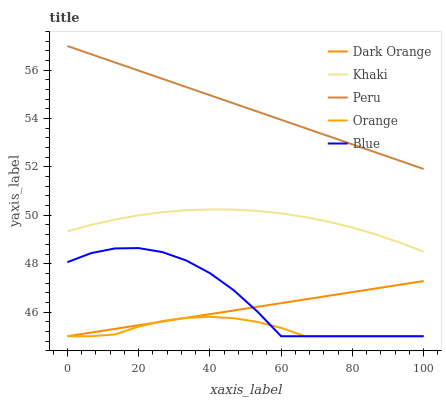Does Dark Orange have the minimum area under the curve?
Answer yes or no. No. Does Dark Orange have the maximum area under the curve?
Answer yes or no. No. Is Khaki the smoothest?
Answer yes or no. No. Is Khaki the roughest?
Answer yes or no. No. Does Khaki have the lowest value?
Answer yes or no. No. Does Dark Orange have the highest value?
Answer yes or no. No. Is Dark Orange less than Khaki?
Answer yes or no. Yes. Is Khaki greater than Blue?
Answer yes or no. Yes. Does Dark Orange intersect Khaki?
Answer yes or no. No. 